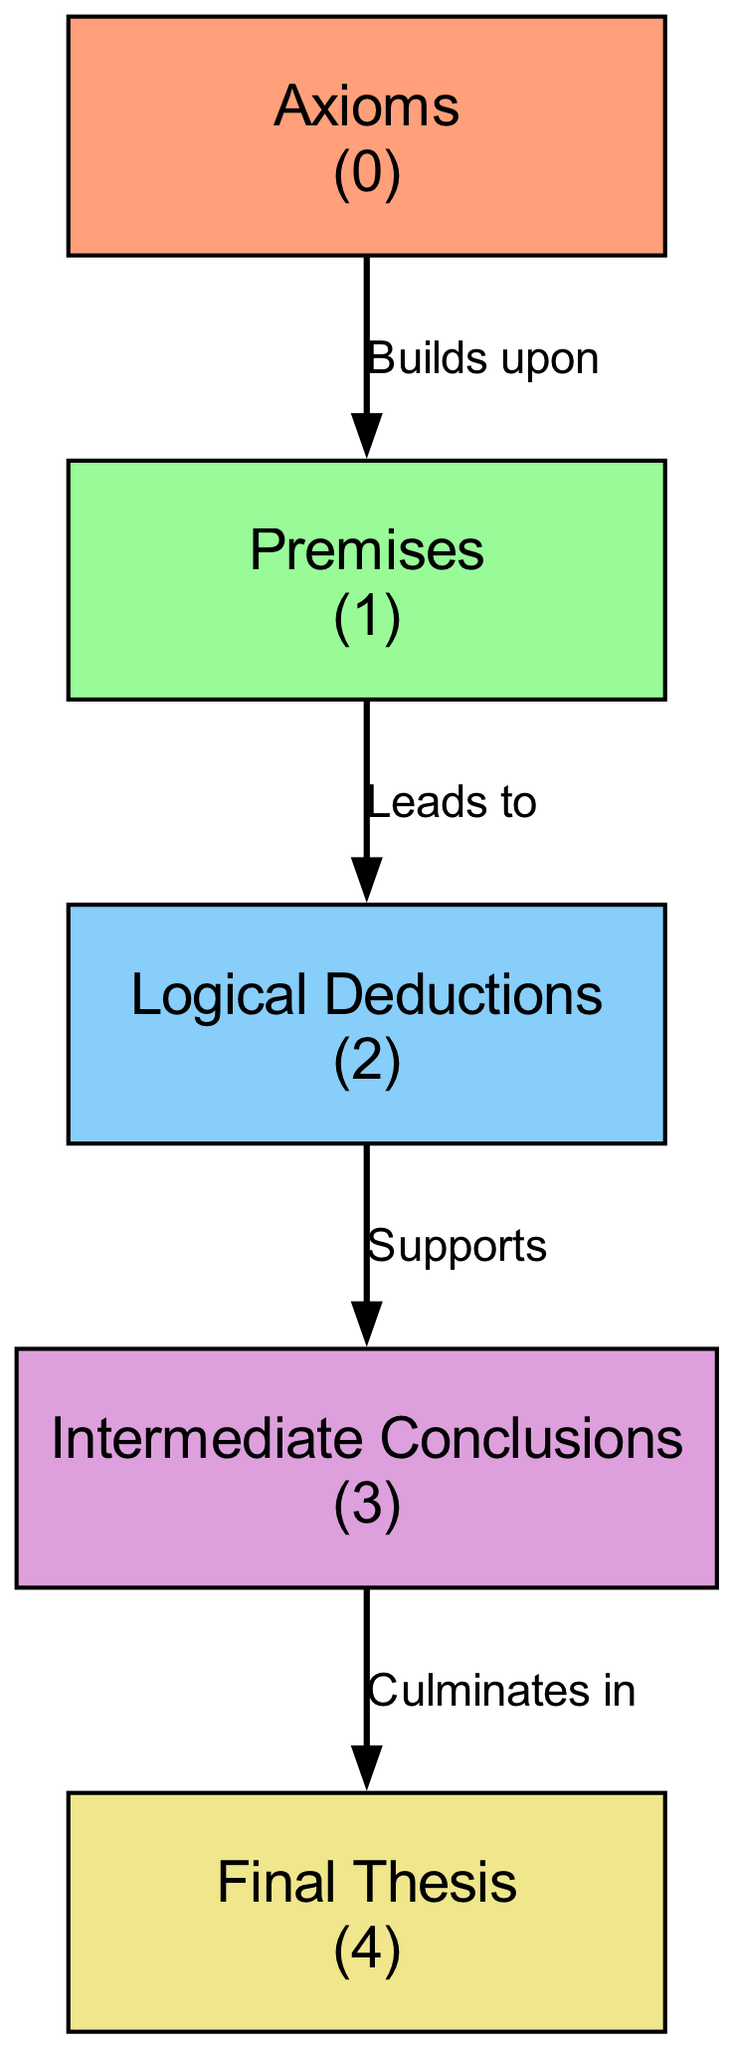What is the first level in the food chain? The first level in the food chain according to the diagram is Axioms. It is explicitly labeled as the initial component.
Answer: Axioms How many total levels are in the food chain? The diagram lists a total of five levels, each representing an important phase within the philosophical argument structure.
Answer: 5 What does "Logical Deductions" lead to? The diagram indicates that Logical Deductions leads to Intermediate Conclusions, as shown by the directed arrow connecting these two nodes.
Answer: Intermediate Conclusions Which node number is associated with the Final Thesis? According to the diagram, the Final Thesis is tagged with the number 4, as specified in its description.
Answer: 4 What connection is established from "Premises" to "Logical Deductions"? The connection shown is labeled "Leads to" which indicates that Premises serve as a basis for generating Logical Deductions in the chain.
Answer: Leads to Which level builds upon the Axioms? The Premises level directly builds upon the Axioms, according to the link denoting the relationship between these two parts of the argument structure.
Answer: Premises What do the Intermediate Conclusions culminate in? The diagram illustrates that Intermediate Conclusions culminate in the Final Thesis, showing the progression towards the ultimate argument conclusion.
Answer: Final Thesis How many connections are represented in the diagram? There are four connections illustrated in the diagram, each detailing the logical flow between consecutive levels in the food chain.
Answer: 4 What does the "Supports" connection represent? This connection indicates that Logical Deductions provides supporting evidence for Intermediate Conclusions, emphasizing the logical structure of the argument process.
Answer: Supports 